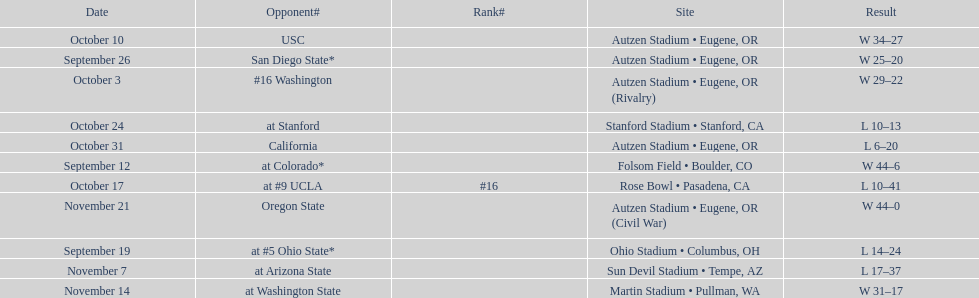Who was their last opponent of the season? Oregon State. 